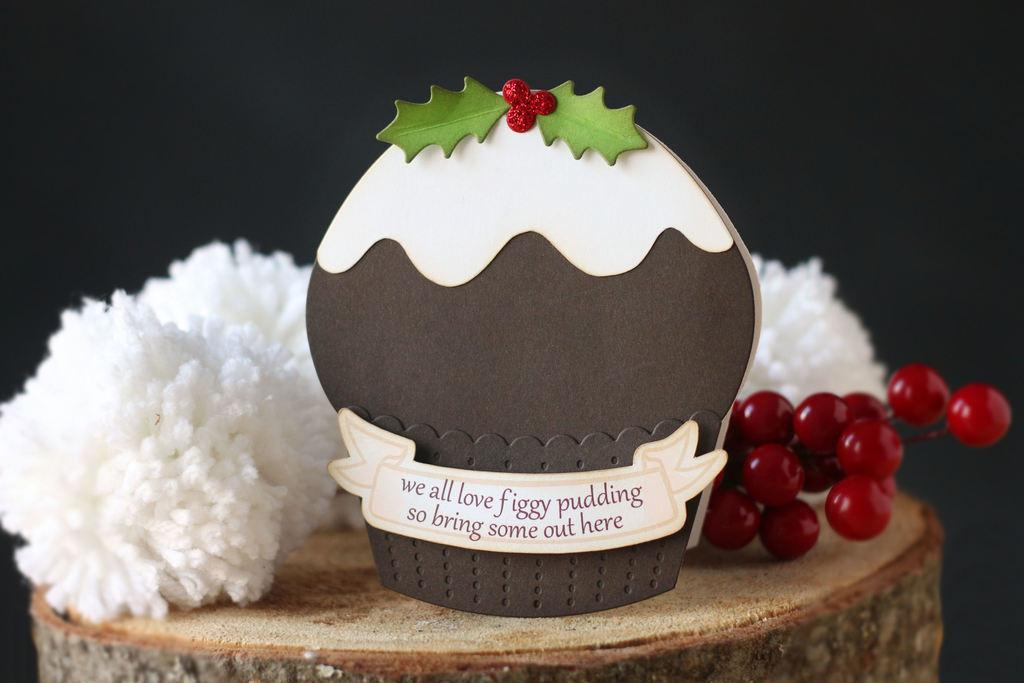What type of food items can be seen in the image? There are fruits in the image. What is the large, flat object in the image? There is a board in the image. What is the surface on which the objects are placed? The objects are on a wooden surface in the image. How would you describe the lighting in the image? The background of the image is dark. What type of brush is being used by the manager in the image? There is no brush or manager present in the image. 